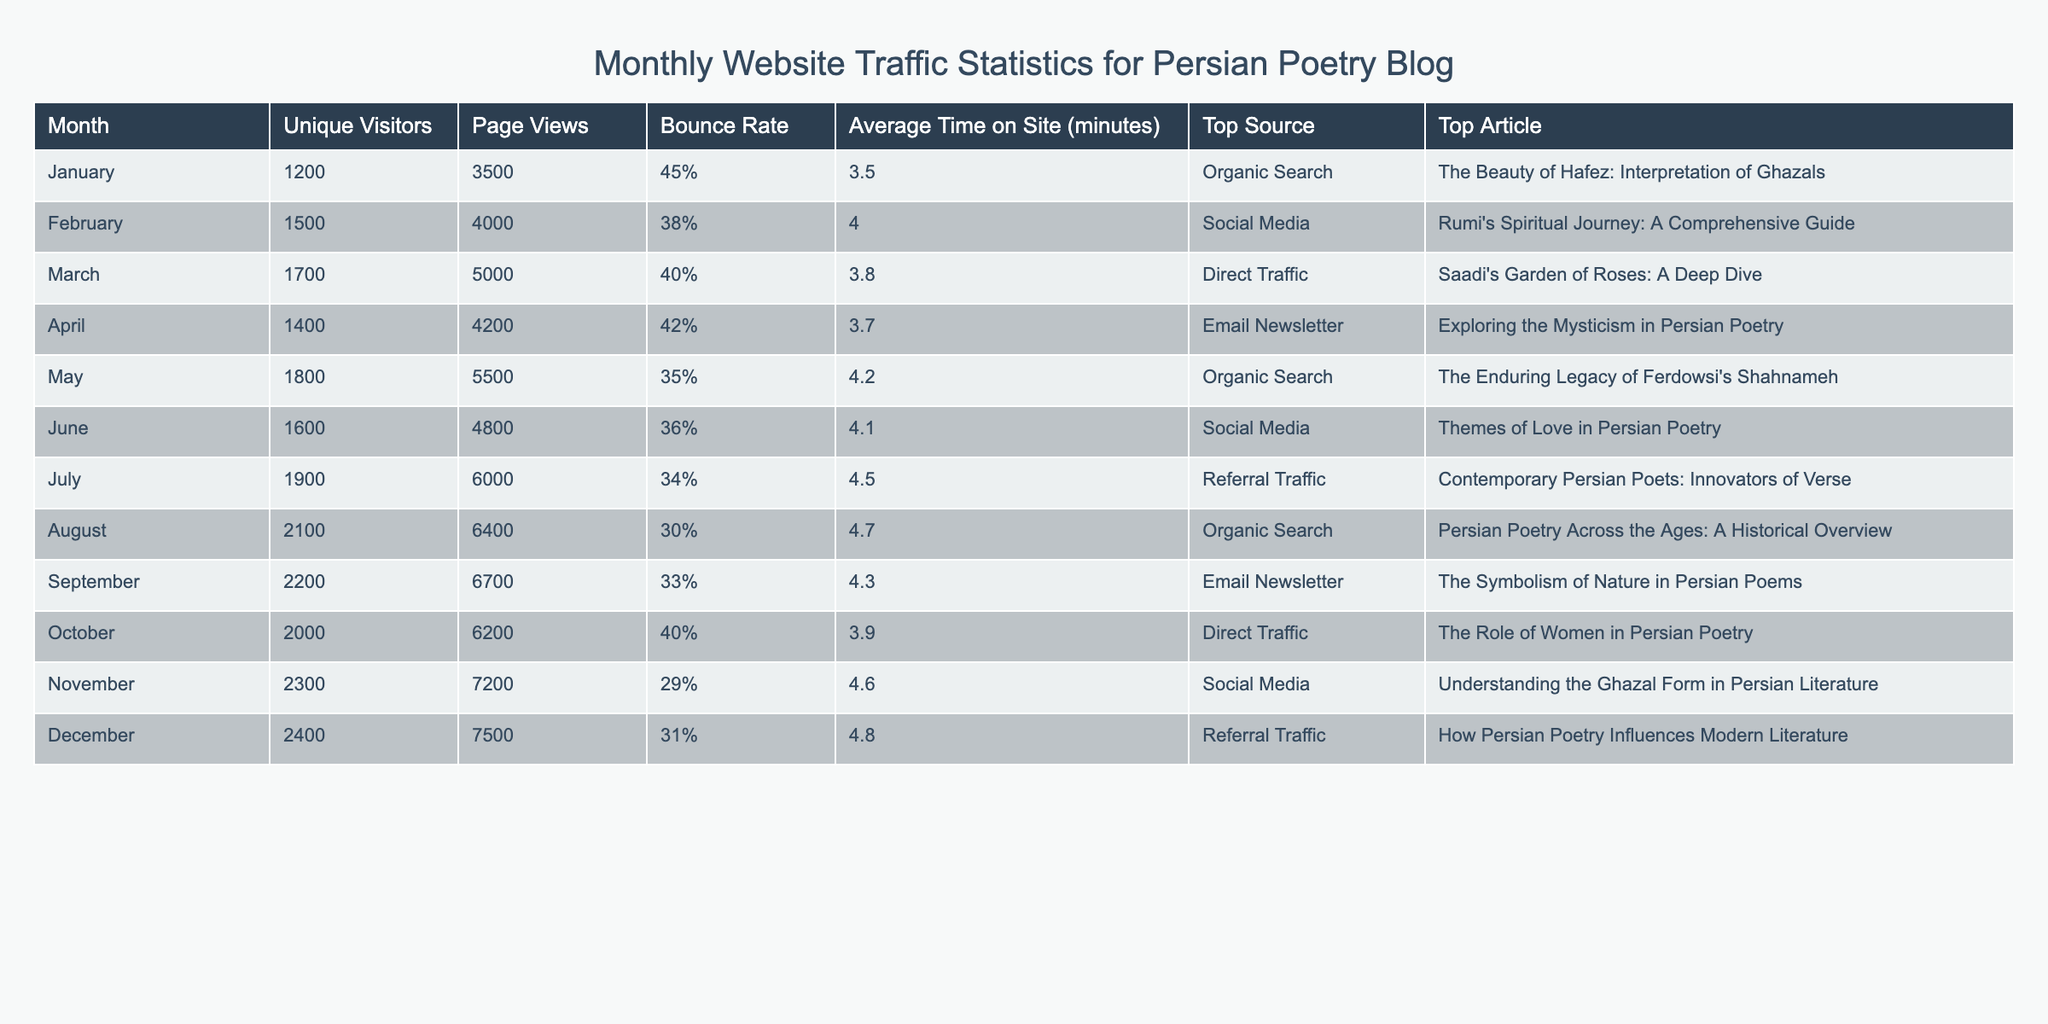What was the unique visitor count in November? Referring to the table, the unique visitor count for November is clearly listed as 2300.
Answer: 2300 Which month had the highest page views? Looking at the page views column, December has the highest number with 7500 page views.
Answer: December What is the average bounce rate over the year? Summing the bounce rates: 45 + 38 + 40 + 42 + 35 + 36 + 34 + 30 + 33 + 40 + 29 + 31 =  476; there are 12 months, so dividing 476 by 12 gives an average bounce rate of approximately 39.67%.
Answer: 39.67% In which month did the blog receive the lowest average time on site? By checking the average time on site column, we find that January has the lowest average time on site at 3.5 minutes.
Answer: January Was there a month with a bounce rate lower than 30%? No, by reviewing the bounce rate values for all months, the lowest bounce rate is 29% in November, but there are no months with a bounce rate below 30%.
Answer: No What were the total unique visitors from January to March? Adding the unique visitors: 1200 (January) + 1500 (February) + 1700 (March) = 4400.
Answer: 4400 Which month had the top traffic source as Direct Traffic? According to the table, both March and October had Direct Traffic as their top source, indicating that these months had a similar traffic source.
Answer: March and October What was the bounce rate difference between the highest and lowest rate? From the table, November has the lowest bounce rate at 29% and January has the highest at 45%. Therefore, the difference is 45% - 29% = 16%.
Answer: 16% Which article had the most unique visitors recorded? Since the table does not specify unique visitors per article, we cannot determine which article received the most unique visitors. However, we can see that view counts differ by month, indicating potential popularity.
Answer: N/A In which month did the blog have more than 2000 unique visitors? The months with more than 2000 unique visitors are August, September, October, November, and December.
Answer: August, September, October, November, December 